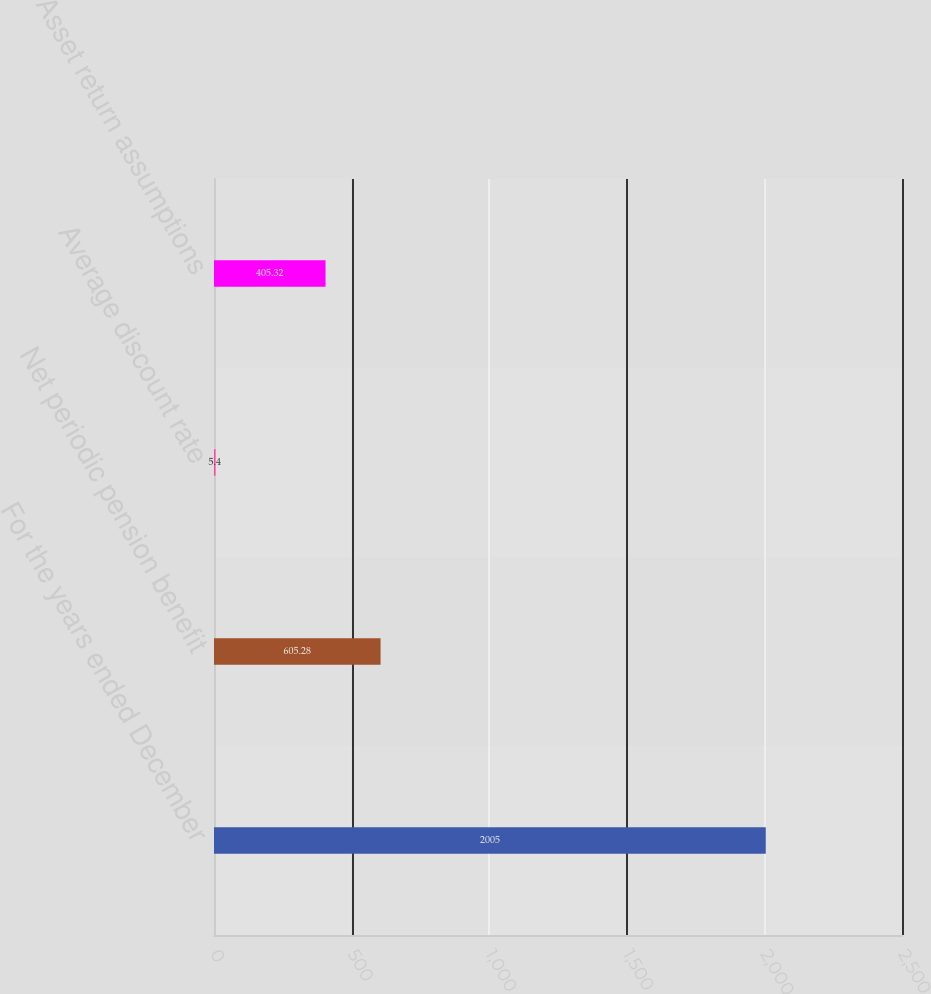<chart> <loc_0><loc_0><loc_500><loc_500><bar_chart><fcel>For the years ended December<fcel>Net periodic pension benefit<fcel>Average discount rate<fcel>Asset return assumptions<nl><fcel>2005<fcel>605.28<fcel>5.4<fcel>405.32<nl></chart> 